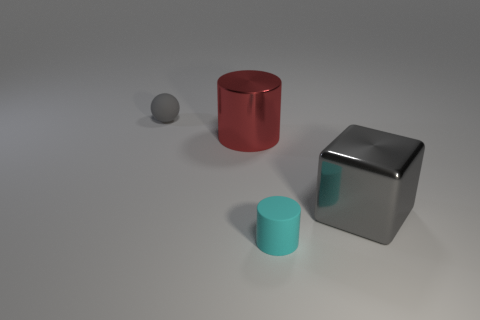Add 2 large metallic objects. How many objects exist? 6 Subtract all balls. How many objects are left? 3 Subtract 0 yellow balls. How many objects are left? 4 Subtract all red shiny cylinders. Subtract all metallic things. How many objects are left? 1 Add 3 small spheres. How many small spheres are left? 4 Add 4 blue metallic balls. How many blue metallic balls exist? 4 